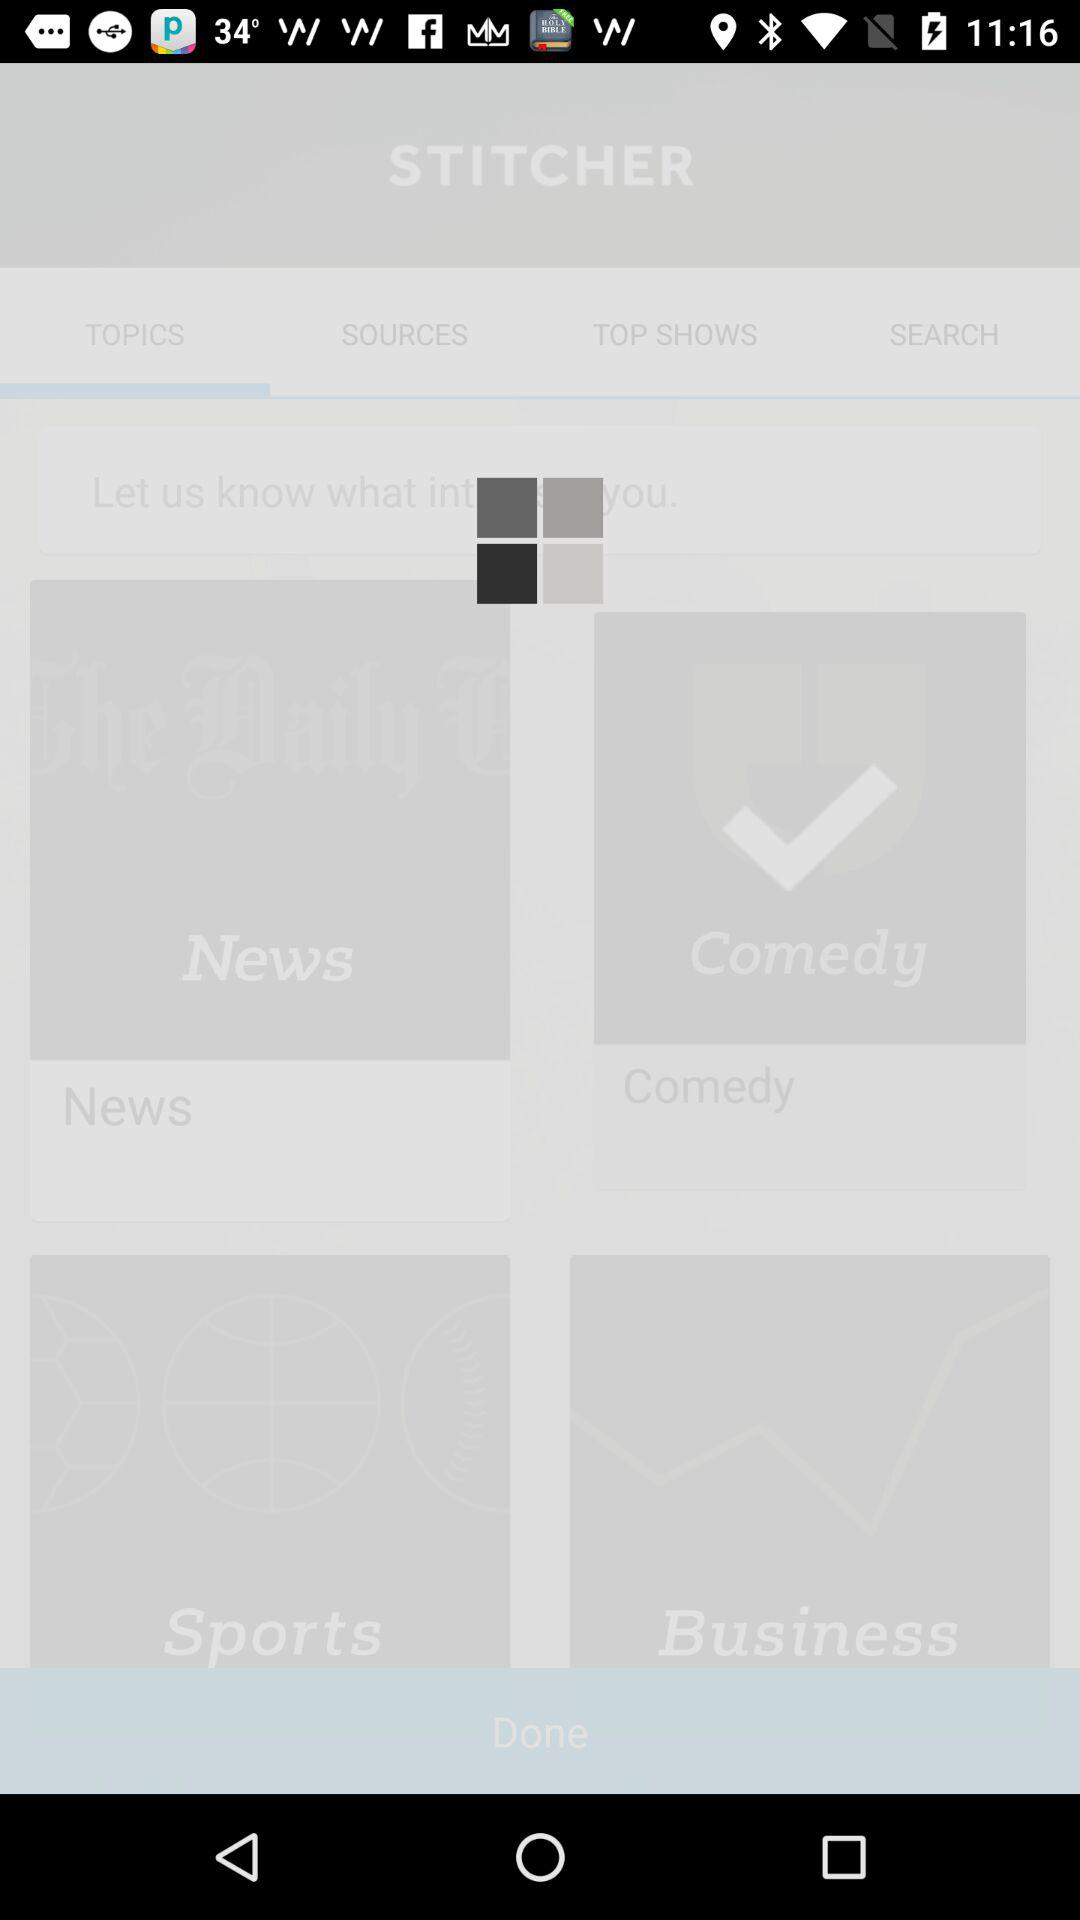How many sign in options are there?
Answer the question using a single word or phrase. 4 